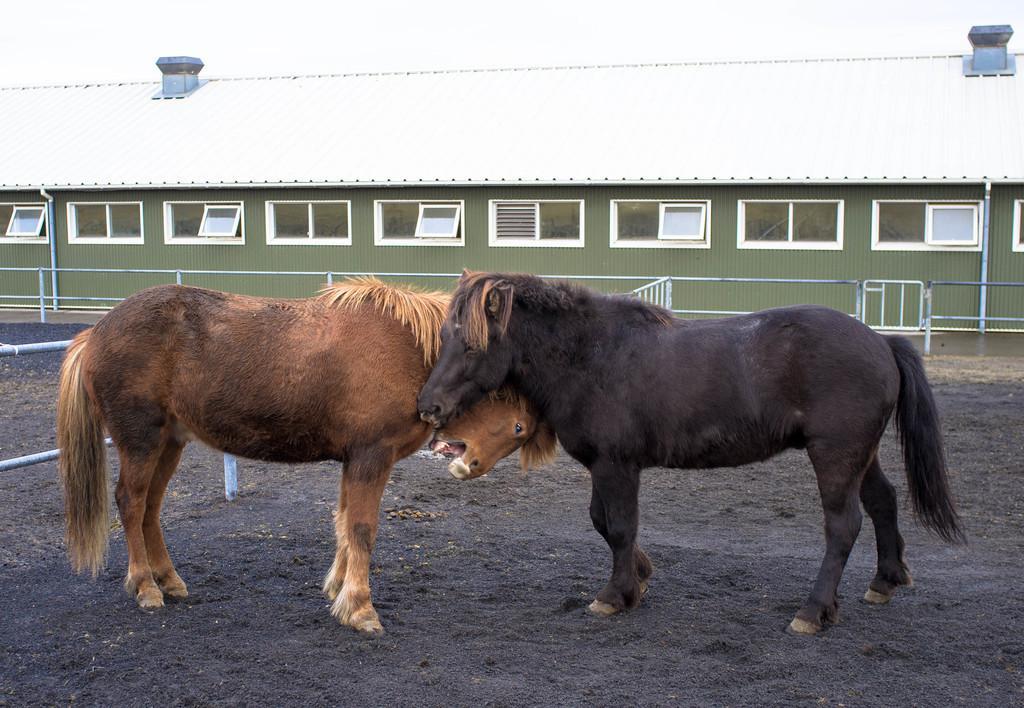Please provide a concise description of this image. In this image, I can see two horses standing. One is brown in color and the other one is black in color. This looks like a shed with windows. These are the roof turbine ventilators. This looks like a small iron gate. 